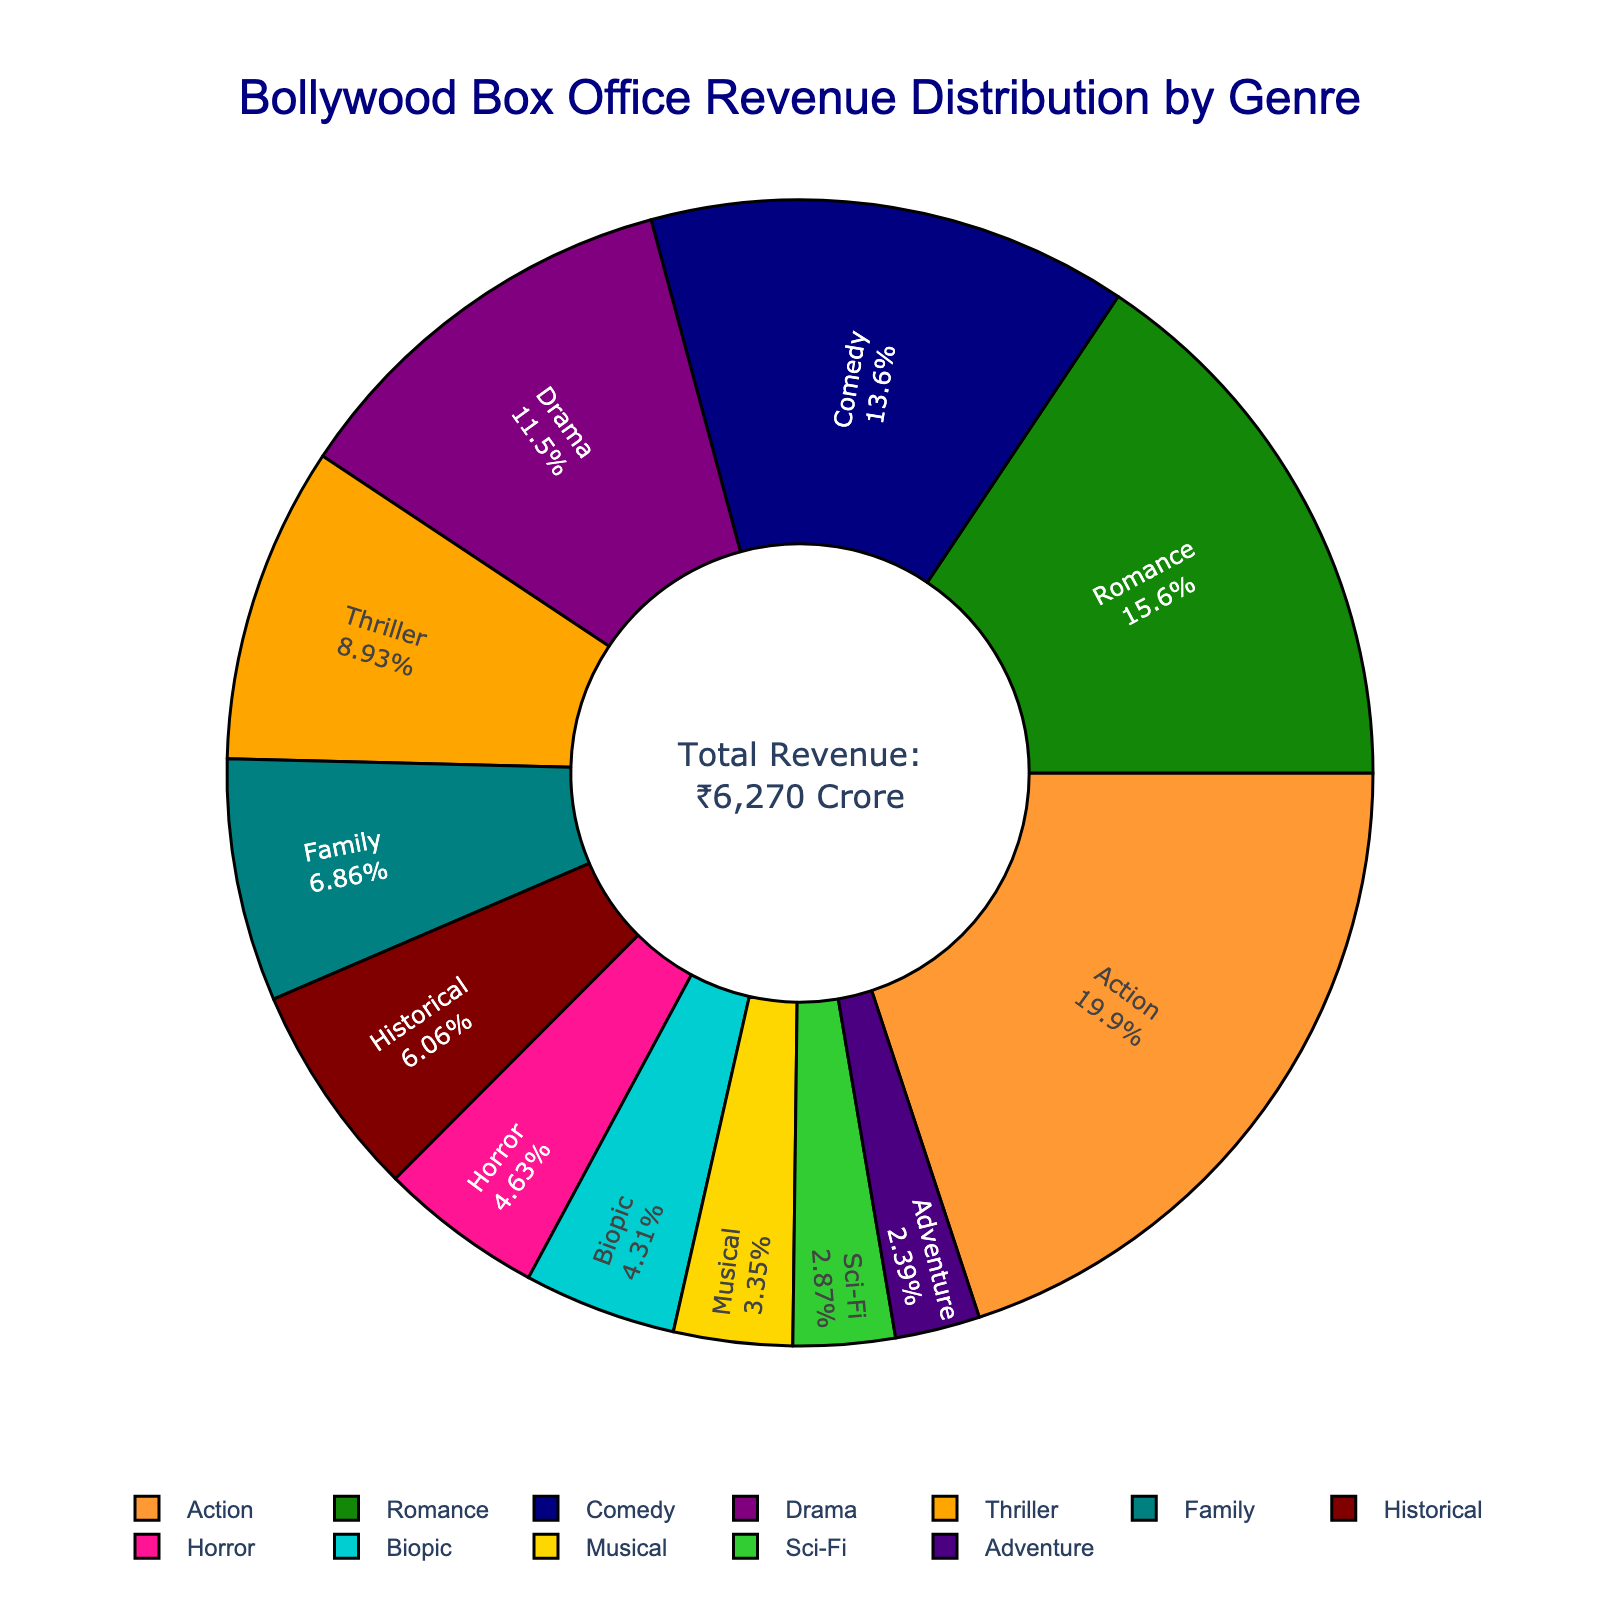what's the total revenue contributed by Action and Romance genres combined? To find the total revenue contributed by both Action and Romance genres, add their respective revenues: Action (₹1250 Crore) + Romance (₹980 Crore) = ₹2230 Crore
Answer: ₹2230 Crore Which genre has the lowest revenue? Looking at the pie chart, the genre with the smallest section corresponds to Adventure, which has the lowest revenue of ₹150 Crore.
Answer: Adventure How does the revenue of Romance compare to Drama? Comparing the percentages, it is evident that Romance has a larger slice than Drama. Specifically, Romance has ₹980 Crore while Drama has ₹720 Crore.
Answer: Romance > Drama What is the median revenue value among all genres? To determine the median revenue, we first list all revenue figures in ascending order: ₹150, ₹180, ₹210, ₹270, ₹290, ₹380, ₹430, ₹560, ₹720, ₹850, ₹980, ₹1250. The middle values are ₹430 (Family) and ₹560 (Thriller). The median is the average of these two: (₹430 + ₹560)/2 = ₹495 Crore
Answer: ₹495 Crore How many genres have a revenue greater than ₹500 Crore? Based on the chart, genres with higher revenue slices and the corresponding figures are: Action (₹1250), Romance (₹980), Comedy (₹850), Drama (₹720), and Thriller (₹560). There are 5 genres in total.
Answer: 5 genres What percentage of total revenue is generated by Musical and Sci-Fi genres combined? First calculate their combined revenue: Musical (₹210 Crore) + Sci-Fi (₹180 Crore) = ₹390 Crore. Total revenue is ₹6270 Crore. The percentage is (₹390/₹6270) * 100 ≈ 6.22%.
Answer: ≈ 6.22% Which genre has a similar color to the Indian national flag and what's its revenue? The genre that is chromatically closest to the colors of the Indian national flag (saffron, white, green) is Action, depicted in a saffron-like color. Action's revenue is ₹1250 Crore.
Answer: Action, ₹1250 Crore Which two genres have the closest revenue values? When examining the chart, Biopic (₹270 Crore) and Horror (₹290 Crore) have the closest revenue figures, differing by only ₹20 Crore.
Answer: Biopic and Horror 